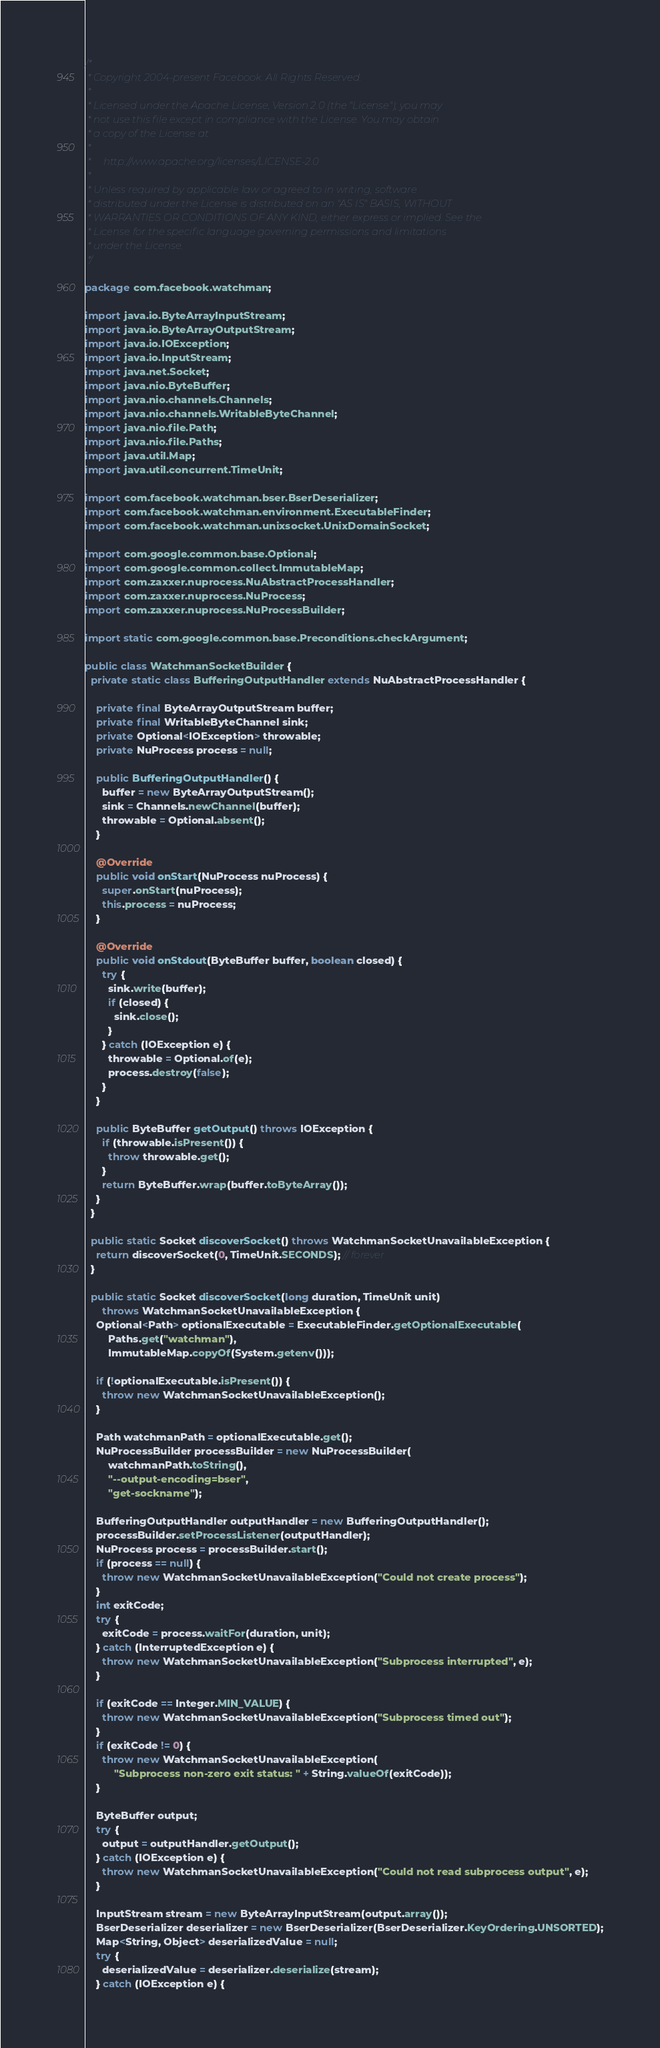<code> <loc_0><loc_0><loc_500><loc_500><_Java_>/*
 * Copyright 2004-present Facebook. All Rights Reserved.
 *
 * Licensed under the Apache License, Version 2.0 (the "License"); you may
 * not use this file except in compliance with the License. You may obtain
 * a copy of the License at
 *
 *     http://www.apache.org/licenses/LICENSE-2.0
 *
 * Unless required by applicable law or agreed to in writing, software
 * distributed under the License is distributed on an "AS IS" BASIS, WITHOUT
 * WARRANTIES OR CONDITIONS OF ANY KIND, either express or implied. See the
 * License for the specific language governing permissions and limitations
 * under the License.
 */

package com.facebook.watchman;

import java.io.ByteArrayInputStream;
import java.io.ByteArrayOutputStream;
import java.io.IOException;
import java.io.InputStream;
import java.net.Socket;
import java.nio.ByteBuffer;
import java.nio.channels.Channels;
import java.nio.channels.WritableByteChannel;
import java.nio.file.Path;
import java.nio.file.Paths;
import java.util.Map;
import java.util.concurrent.TimeUnit;

import com.facebook.watchman.bser.BserDeserializer;
import com.facebook.watchman.environment.ExecutableFinder;
import com.facebook.watchman.unixsocket.UnixDomainSocket;

import com.google.common.base.Optional;
import com.google.common.collect.ImmutableMap;
import com.zaxxer.nuprocess.NuAbstractProcessHandler;
import com.zaxxer.nuprocess.NuProcess;
import com.zaxxer.nuprocess.NuProcessBuilder;

import static com.google.common.base.Preconditions.checkArgument;

public class WatchmanSocketBuilder {
  private static class BufferingOutputHandler extends NuAbstractProcessHandler {

    private final ByteArrayOutputStream buffer;
    private final WritableByteChannel sink;
    private Optional<IOException> throwable;
    private NuProcess process = null;

    public BufferingOutputHandler() {
      buffer = new ByteArrayOutputStream();
      sink = Channels.newChannel(buffer);
      throwable = Optional.absent();
    }

    @Override
    public void onStart(NuProcess nuProcess) {
      super.onStart(nuProcess);
      this.process = nuProcess;
    }

    @Override
    public void onStdout(ByteBuffer buffer, boolean closed) {
      try {
        sink.write(buffer);
        if (closed) {
          sink.close();
        }
      } catch (IOException e) {
        throwable = Optional.of(e);
        process.destroy(false);
      }
    }

    public ByteBuffer getOutput() throws IOException {
      if (throwable.isPresent()) {
        throw throwable.get();
      }
      return ByteBuffer.wrap(buffer.toByteArray());
    }
  }

  public static Socket discoverSocket() throws WatchmanSocketUnavailableException {
    return discoverSocket(0, TimeUnit.SECONDS); // forever
  }

  public static Socket discoverSocket(long duration, TimeUnit unit)
      throws WatchmanSocketUnavailableException {
    Optional<Path> optionalExecutable = ExecutableFinder.getOptionalExecutable(
        Paths.get("watchman"),
        ImmutableMap.copyOf(System.getenv()));

    if (!optionalExecutable.isPresent()) {
      throw new WatchmanSocketUnavailableException();
    }

    Path watchmanPath = optionalExecutable.get();
    NuProcessBuilder processBuilder = new NuProcessBuilder(
        watchmanPath.toString(),
        "--output-encoding=bser",
        "get-sockname");

    BufferingOutputHandler outputHandler = new BufferingOutputHandler();
    processBuilder.setProcessListener(outputHandler);
    NuProcess process = processBuilder.start();
    if (process == null) {
      throw new WatchmanSocketUnavailableException("Could not create process");
    }
    int exitCode;
    try {
      exitCode = process.waitFor(duration, unit);
    } catch (InterruptedException e) {
      throw new WatchmanSocketUnavailableException("Subprocess interrupted", e);
    }

    if (exitCode == Integer.MIN_VALUE) {
      throw new WatchmanSocketUnavailableException("Subprocess timed out");
    }
    if (exitCode != 0) {
      throw new WatchmanSocketUnavailableException(
          "Subprocess non-zero exit status: " + String.valueOf(exitCode));
    }

    ByteBuffer output;
    try {
      output = outputHandler.getOutput();
    } catch (IOException e) {
      throw new WatchmanSocketUnavailableException("Could not read subprocess output", e);
    }

    InputStream stream = new ByteArrayInputStream(output.array());
    BserDeserializer deserializer = new BserDeserializer(BserDeserializer.KeyOrdering.UNSORTED);
    Map<String, Object> deserializedValue = null;
    try {
      deserializedValue = deserializer.deserialize(stream);
    } catch (IOException e) {</code> 